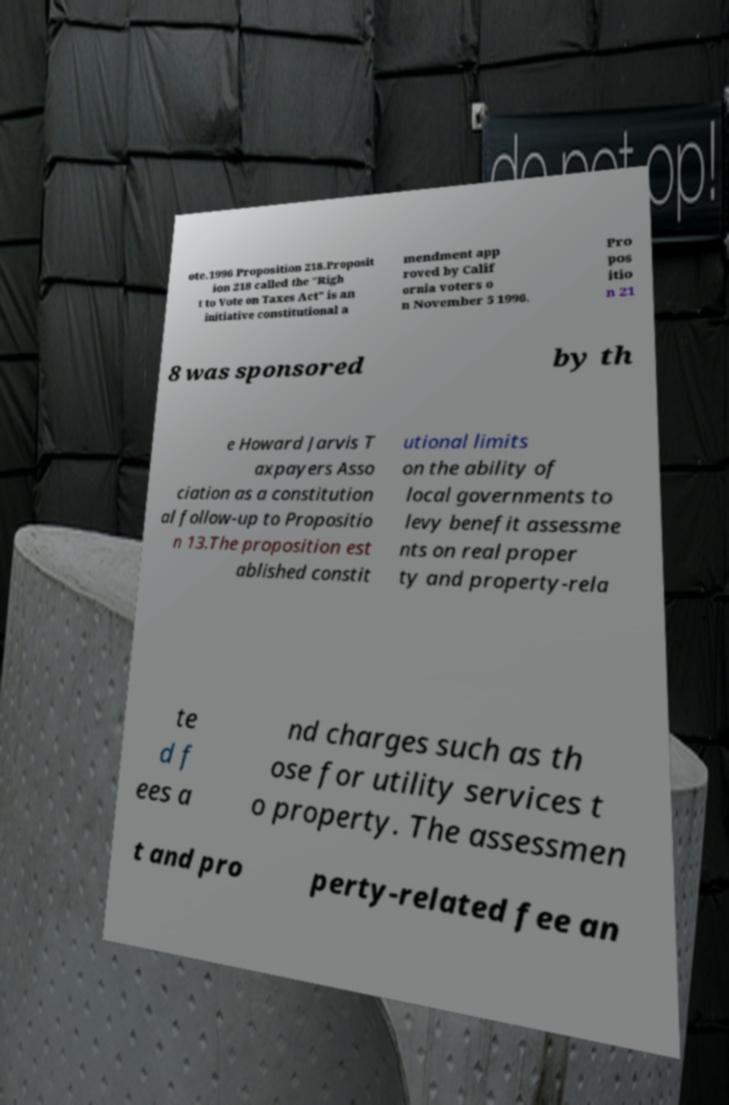Please identify and transcribe the text found in this image. ote.1996 Proposition 218.Proposit ion 218 called the "Righ t to Vote on Taxes Act" is an initiative constitutional a mendment app roved by Calif ornia voters o n November 5 1996. Pro pos itio n 21 8 was sponsored by th e Howard Jarvis T axpayers Asso ciation as a constitution al follow-up to Propositio n 13.The proposition est ablished constit utional limits on the ability of local governments to levy benefit assessme nts on real proper ty and property-rela te d f ees a nd charges such as th ose for utility services t o property. The assessmen t and pro perty-related fee an 